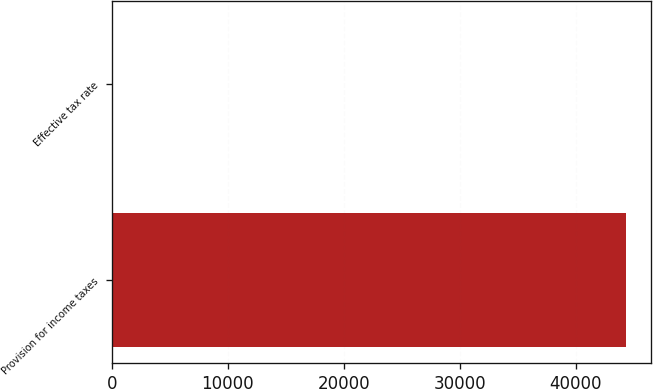Convert chart to OTSL. <chart><loc_0><loc_0><loc_500><loc_500><bar_chart><fcel>Provision for income taxes<fcel>Effective tax rate<nl><fcel>44317<fcel>40<nl></chart> 